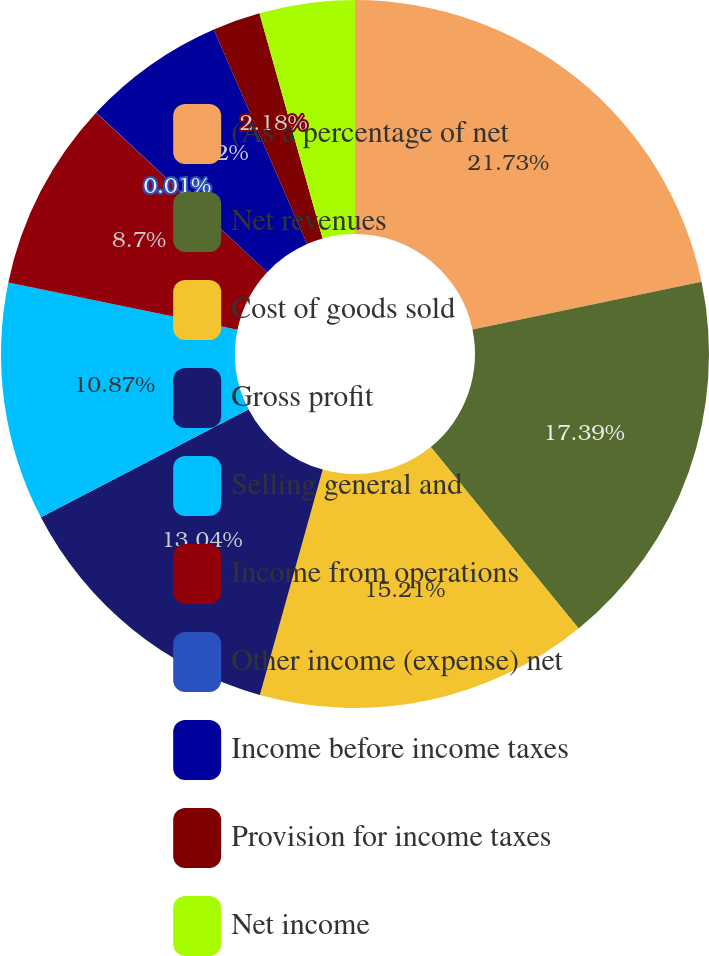Convert chart to OTSL. <chart><loc_0><loc_0><loc_500><loc_500><pie_chart><fcel>(As a percentage of net<fcel>Net revenues<fcel>Cost of goods sold<fcel>Gross profit<fcel>Selling general and<fcel>Income from operations<fcel>Other income (expense) net<fcel>Income before income taxes<fcel>Provision for income taxes<fcel>Net income<nl><fcel>21.73%<fcel>17.39%<fcel>15.21%<fcel>13.04%<fcel>10.87%<fcel>8.7%<fcel>0.01%<fcel>6.52%<fcel>2.18%<fcel>4.35%<nl></chart> 